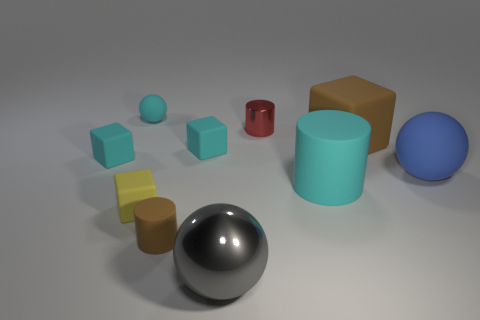If I were to group these objects by texture, how would the groups be organized? There seem to be two main texture groups visible in the image. The first group includes objects with a matte surface texture that absorbs light and appears flatter, including the big cyan cylinder and the yellow cube. The second group consists of objects with shiny, reflective surfaces, like the large chrome sphere in the foreground and the smaller blue sphere towards the center of the composition. 